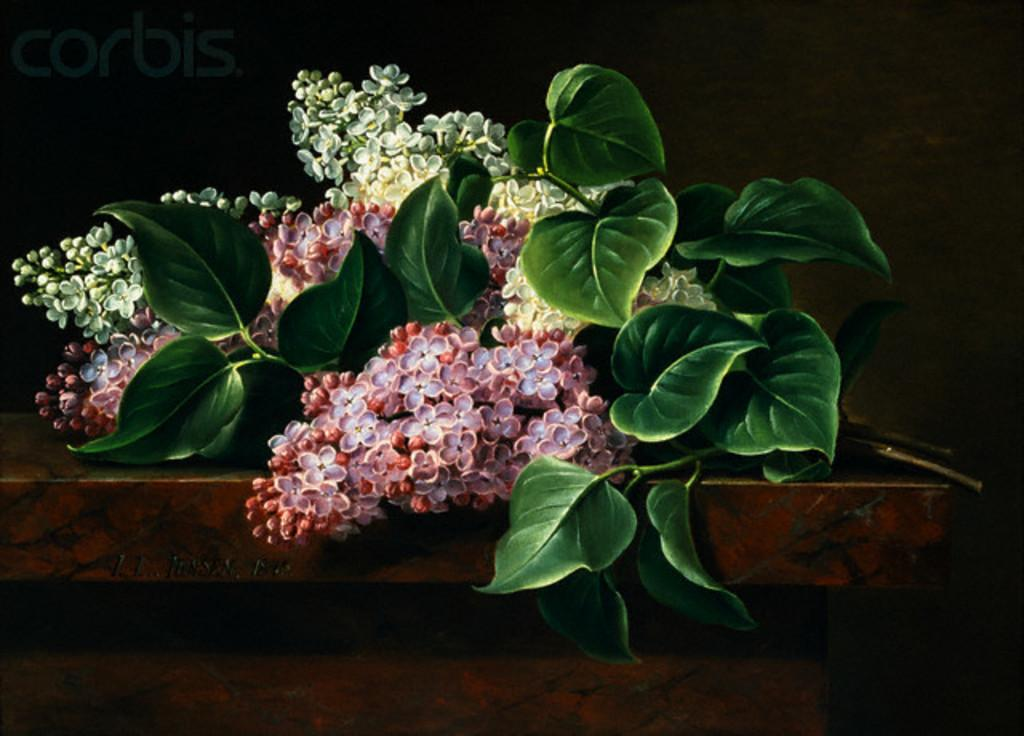What type of decorative items can be seen in the foreground of the image? There are artificial flowers and leaves placed on a table in the foreground of the image. What is visible in the background of the image? There is a wall in the background of the image. What type of butter is being used to create the patterns on the wall in the image? There is no butter present in the image, nor are there any patterns on the wall. 